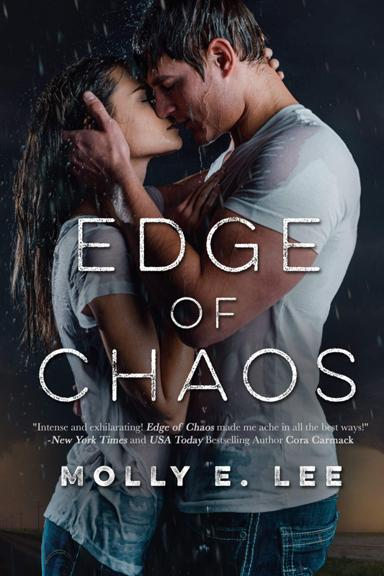What is the title of the book mentioned in the image? The title of the book is "Edge of Chaos" by Molly E. Lee. What does the reviewer say about the book? The reviewer, who is a New York Times and USA Today bestselling author, Cora Carmack, called the book "intense and exhilarating" and said that it made her "ache in all the best ways." 